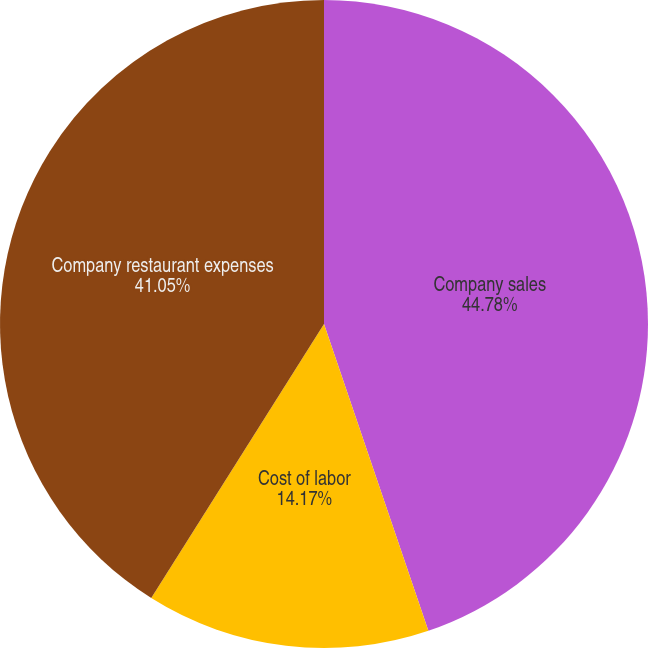Convert chart to OTSL. <chart><loc_0><loc_0><loc_500><loc_500><pie_chart><fcel>Company sales<fcel>Cost of labor<fcel>Company restaurant expenses<nl><fcel>44.78%<fcel>14.17%<fcel>41.05%<nl></chart> 